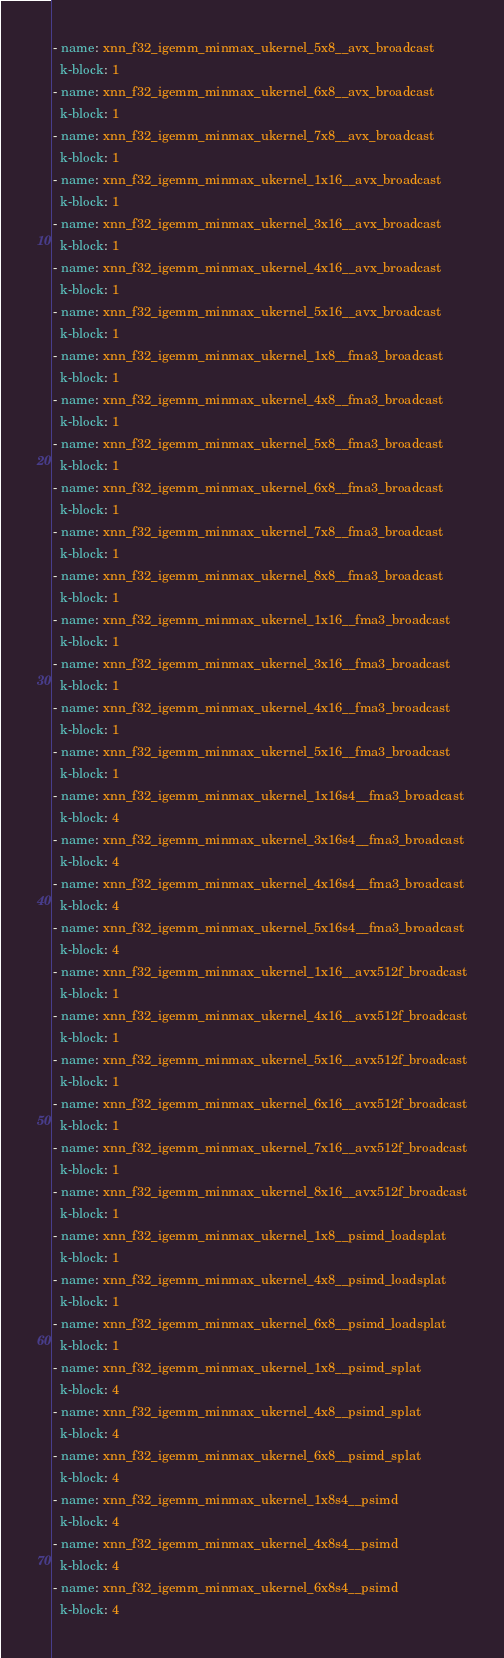<code> <loc_0><loc_0><loc_500><loc_500><_YAML_>- name: xnn_f32_igemm_minmax_ukernel_5x8__avx_broadcast
  k-block: 1
- name: xnn_f32_igemm_minmax_ukernel_6x8__avx_broadcast
  k-block: 1
- name: xnn_f32_igemm_minmax_ukernel_7x8__avx_broadcast
  k-block: 1
- name: xnn_f32_igemm_minmax_ukernel_1x16__avx_broadcast
  k-block: 1
- name: xnn_f32_igemm_minmax_ukernel_3x16__avx_broadcast
  k-block: 1
- name: xnn_f32_igemm_minmax_ukernel_4x16__avx_broadcast
  k-block: 1
- name: xnn_f32_igemm_minmax_ukernel_5x16__avx_broadcast
  k-block: 1
- name: xnn_f32_igemm_minmax_ukernel_1x8__fma3_broadcast
  k-block: 1
- name: xnn_f32_igemm_minmax_ukernel_4x8__fma3_broadcast
  k-block: 1
- name: xnn_f32_igemm_minmax_ukernel_5x8__fma3_broadcast
  k-block: 1
- name: xnn_f32_igemm_minmax_ukernel_6x8__fma3_broadcast
  k-block: 1
- name: xnn_f32_igemm_minmax_ukernel_7x8__fma3_broadcast
  k-block: 1
- name: xnn_f32_igemm_minmax_ukernel_8x8__fma3_broadcast
  k-block: 1
- name: xnn_f32_igemm_minmax_ukernel_1x16__fma3_broadcast
  k-block: 1
- name: xnn_f32_igemm_minmax_ukernel_3x16__fma3_broadcast
  k-block: 1
- name: xnn_f32_igemm_minmax_ukernel_4x16__fma3_broadcast
  k-block: 1
- name: xnn_f32_igemm_minmax_ukernel_5x16__fma3_broadcast
  k-block: 1
- name: xnn_f32_igemm_minmax_ukernel_1x16s4__fma3_broadcast
  k-block: 4
- name: xnn_f32_igemm_minmax_ukernel_3x16s4__fma3_broadcast
  k-block: 4
- name: xnn_f32_igemm_minmax_ukernel_4x16s4__fma3_broadcast
  k-block: 4
- name: xnn_f32_igemm_minmax_ukernel_5x16s4__fma3_broadcast
  k-block: 4
- name: xnn_f32_igemm_minmax_ukernel_1x16__avx512f_broadcast
  k-block: 1
- name: xnn_f32_igemm_minmax_ukernel_4x16__avx512f_broadcast
  k-block: 1
- name: xnn_f32_igemm_minmax_ukernel_5x16__avx512f_broadcast
  k-block: 1
- name: xnn_f32_igemm_minmax_ukernel_6x16__avx512f_broadcast
  k-block: 1
- name: xnn_f32_igemm_minmax_ukernel_7x16__avx512f_broadcast
  k-block: 1
- name: xnn_f32_igemm_minmax_ukernel_8x16__avx512f_broadcast
  k-block: 1
- name: xnn_f32_igemm_minmax_ukernel_1x8__psimd_loadsplat
  k-block: 1
- name: xnn_f32_igemm_minmax_ukernel_4x8__psimd_loadsplat
  k-block: 1
- name: xnn_f32_igemm_minmax_ukernel_6x8__psimd_loadsplat
  k-block: 1
- name: xnn_f32_igemm_minmax_ukernel_1x8__psimd_splat
  k-block: 4
- name: xnn_f32_igemm_minmax_ukernel_4x8__psimd_splat
  k-block: 4
- name: xnn_f32_igemm_minmax_ukernel_6x8__psimd_splat
  k-block: 4
- name: xnn_f32_igemm_minmax_ukernel_1x8s4__psimd
  k-block: 4
- name: xnn_f32_igemm_minmax_ukernel_4x8s4__psimd
  k-block: 4
- name: xnn_f32_igemm_minmax_ukernel_6x8s4__psimd
  k-block: 4</code> 